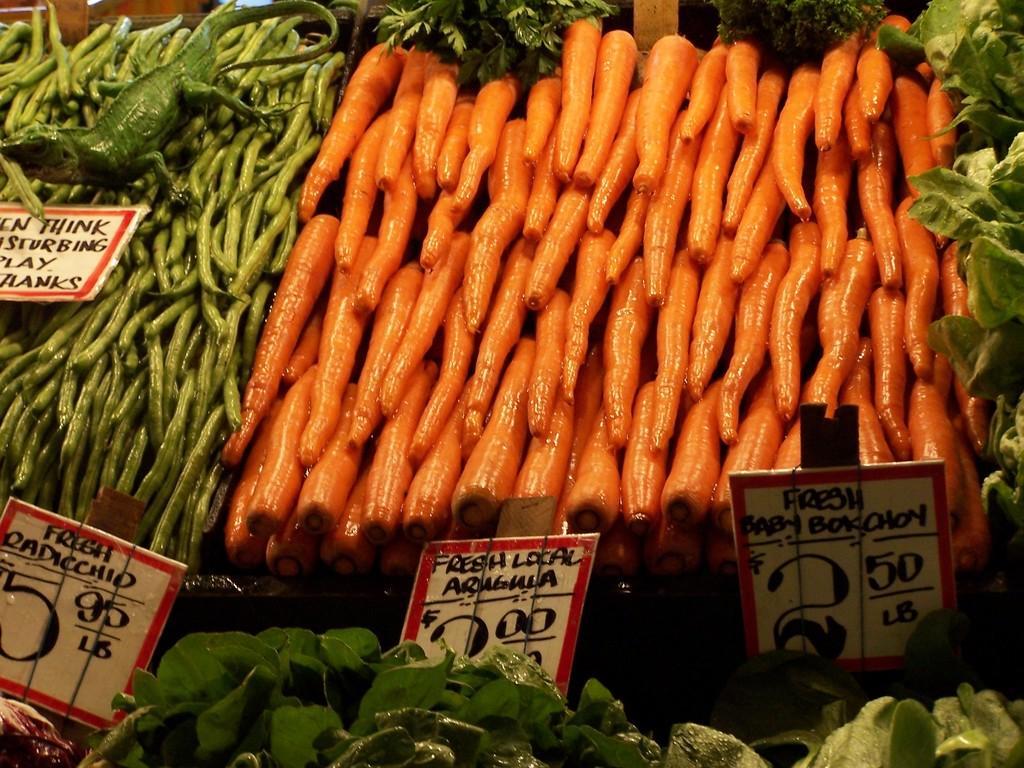Can you describe this image briefly? In this image we can see few vegetables and boards with text. 